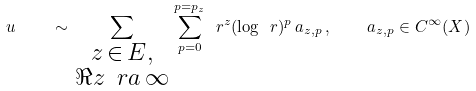Convert formula to latex. <formula><loc_0><loc_0><loc_500><loc_500>u \quad \sim \sum _ { \begin{smallmatrix} z \, \in \, E , \\ \Re z \, \ r a \, \infty \end{smallmatrix} } \sum _ { p = 0 } ^ { p = p _ { z } } \ r ^ { z } ( \log \ r ) ^ { p } \, a _ { z , p } \, , \quad a _ { z , p } \in C ^ { \infty } ( X )</formula> 